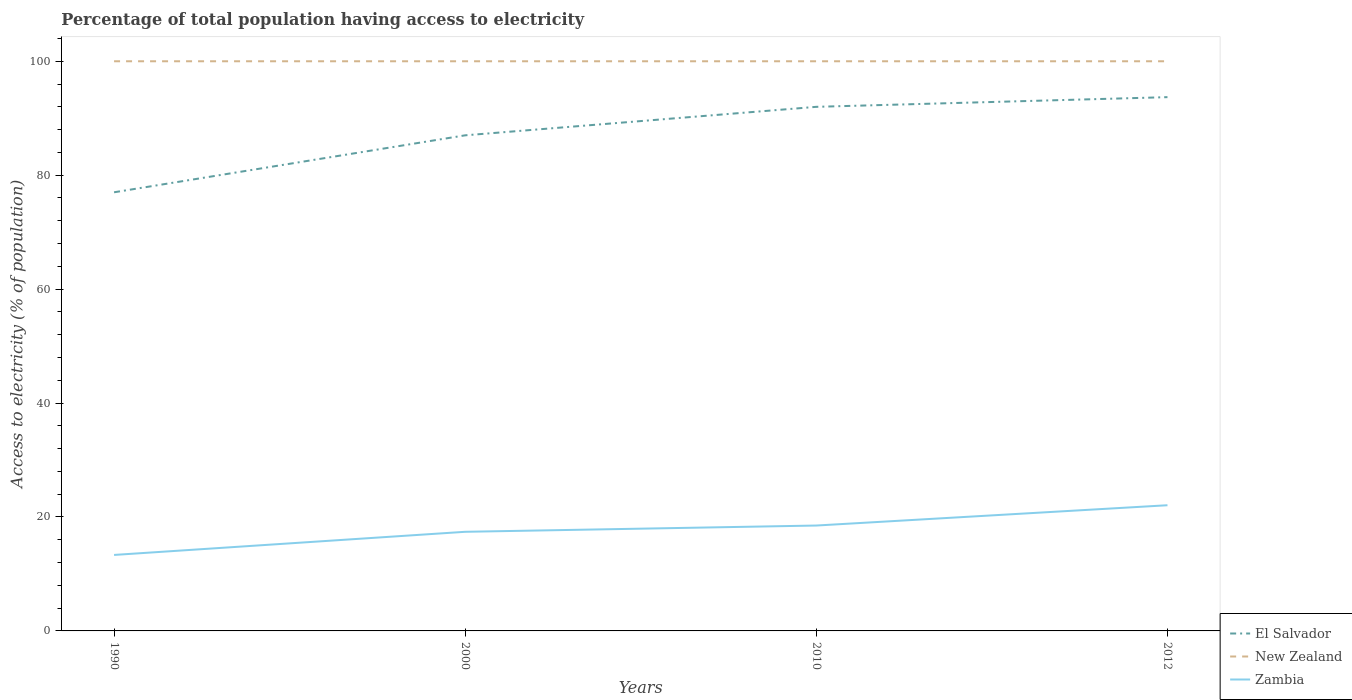How many different coloured lines are there?
Keep it short and to the point. 3. Across all years, what is the maximum percentage of population that have access to electricity in Zambia?
Your answer should be very brief. 13.34. What is the total percentage of population that have access to electricity in New Zealand in the graph?
Offer a very short reply. 0. What is the difference between the highest and the second highest percentage of population that have access to electricity in New Zealand?
Provide a short and direct response. 0. What is the difference between two consecutive major ticks on the Y-axis?
Keep it short and to the point. 20. Are the values on the major ticks of Y-axis written in scientific E-notation?
Your answer should be very brief. No. How are the legend labels stacked?
Make the answer very short. Vertical. What is the title of the graph?
Give a very brief answer. Percentage of total population having access to electricity. What is the label or title of the X-axis?
Provide a succinct answer. Years. What is the label or title of the Y-axis?
Your answer should be compact. Access to electricity (% of population). What is the Access to electricity (% of population) in Zambia in 1990?
Offer a very short reply. 13.34. What is the Access to electricity (% of population) in El Salvador in 2000?
Ensure brevity in your answer.  87. What is the Access to electricity (% of population) of Zambia in 2000?
Offer a terse response. 17.4. What is the Access to electricity (% of population) of El Salvador in 2010?
Give a very brief answer. 92. What is the Access to electricity (% of population) in New Zealand in 2010?
Offer a very short reply. 100. What is the Access to electricity (% of population) of Zambia in 2010?
Keep it short and to the point. 18.5. What is the Access to electricity (% of population) in El Salvador in 2012?
Provide a short and direct response. 93.7. What is the Access to electricity (% of population) in New Zealand in 2012?
Offer a very short reply. 100. What is the Access to electricity (% of population) of Zambia in 2012?
Offer a very short reply. 22.06. Across all years, what is the maximum Access to electricity (% of population) of El Salvador?
Your answer should be very brief. 93.7. Across all years, what is the maximum Access to electricity (% of population) of Zambia?
Your response must be concise. 22.06. Across all years, what is the minimum Access to electricity (% of population) of El Salvador?
Your response must be concise. 77. Across all years, what is the minimum Access to electricity (% of population) in Zambia?
Your answer should be very brief. 13.34. What is the total Access to electricity (% of population) of El Salvador in the graph?
Give a very brief answer. 349.7. What is the total Access to electricity (% of population) in Zambia in the graph?
Make the answer very short. 71.3. What is the difference between the Access to electricity (% of population) in El Salvador in 1990 and that in 2000?
Provide a short and direct response. -10. What is the difference between the Access to electricity (% of population) in New Zealand in 1990 and that in 2000?
Give a very brief answer. 0. What is the difference between the Access to electricity (% of population) in Zambia in 1990 and that in 2000?
Provide a short and direct response. -4.06. What is the difference between the Access to electricity (% of population) in El Salvador in 1990 and that in 2010?
Give a very brief answer. -15. What is the difference between the Access to electricity (% of population) in New Zealand in 1990 and that in 2010?
Give a very brief answer. 0. What is the difference between the Access to electricity (% of population) of Zambia in 1990 and that in 2010?
Give a very brief answer. -5.16. What is the difference between the Access to electricity (% of population) in El Salvador in 1990 and that in 2012?
Provide a succinct answer. -16.7. What is the difference between the Access to electricity (% of population) of New Zealand in 1990 and that in 2012?
Offer a very short reply. 0. What is the difference between the Access to electricity (% of population) of Zambia in 1990 and that in 2012?
Your response must be concise. -8.72. What is the difference between the Access to electricity (% of population) of New Zealand in 2000 and that in 2010?
Provide a short and direct response. 0. What is the difference between the Access to electricity (% of population) in Zambia in 2000 and that in 2010?
Your response must be concise. -1.1. What is the difference between the Access to electricity (% of population) of El Salvador in 2000 and that in 2012?
Provide a short and direct response. -6.7. What is the difference between the Access to electricity (% of population) of Zambia in 2000 and that in 2012?
Make the answer very short. -4.66. What is the difference between the Access to electricity (% of population) in El Salvador in 2010 and that in 2012?
Give a very brief answer. -1.7. What is the difference between the Access to electricity (% of population) of New Zealand in 2010 and that in 2012?
Make the answer very short. 0. What is the difference between the Access to electricity (% of population) of Zambia in 2010 and that in 2012?
Provide a succinct answer. -3.56. What is the difference between the Access to electricity (% of population) of El Salvador in 1990 and the Access to electricity (% of population) of New Zealand in 2000?
Provide a succinct answer. -23. What is the difference between the Access to electricity (% of population) of El Salvador in 1990 and the Access to electricity (% of population) of Zambia in 2000?
Your answer should be compact. 59.6. What is the difference between the Access to electricity (% of population) in New Zealand in 1990 and the Access to electricity (% of population) in Zambia in 2000?
Your answer should be very brief. 82.6. What is the difference between the Access to electricity (% of population) of El Salvador in 1990 and the Access to electricity (% of population) of Zambia in 2010?
Provide a short and direct response. 58.5. What is the difference between the Access to electricity (% of population) of New Zealand in 1990 and the Access to electricity (% of population) of Zambia in 2010?
Your answer should be compact. 81.5. What is the difference between the Access to electricity (% of population) of El Salvador in 1990 and the Access to electricity (% of population) of Zambia in 2012?
Offer a terse response. 54.94. What is the difference between the Access to electricity (% of population) in New Zealand in 1990 and the Access to electricity (% of population) in Zambia in 2012?
Your answer should be very brief. 77.94. What is the difference between the Access to electricity (% of population) of El Salvador in 2000 and the Access to electricity (% of population) of New Zealand in 2010?
Offer a terse response. -13. What is the difference between the Access to electricity (% of population) of El Salvador in 2000 and the Access to electricity (% of population) of Zambia in 2010?
Your answer should be compact. 68.5. What is the difference between the Access to electricity (% of population) of New Zealand in 2000 and the Access to electricity (% of population) of Zambia in 2010?
Ensure brevity in your answer.  81.5. What is the difference between the Access to electricity (% of population) in El Salvador in 2000 and the Access to electricity (% of population) in New Zealand in 2012?
Ensure brevity in your answer.  -13. What is the difference between the Access to electricity (% of population) in El Salvador in 2000 and the Access to electricity (% of population) in Zambia in 2012?
Give a very brief answer. 64.94. What is the difference between the Access to electricity (% of population) in New Zealand in 2000 and the Access to electricity (% of population) in Zambia in 2012?
Your answer should be compact. 77.94. What is the difference between the Access to electricity (% of population) in El Salvador in 2010 and the Access to electricity (% of population) in New Zealand in 2012?
Make the answer very short. -8. What is the difference between the Access to electricity (% of population) in El Salvador in 2010 and the Access to electricity (% of population) in Zambia in 2012?
Give a very brief answer. 69.94. What is the difference between the Access to electricity (% of population) in New Zealand in 2010 and the Access to electricity (% of population) in Zambia in 2012?
Offer a very short reply. 77.94. What is the average Access to electricity (% of population) of El Salvador per year?
Provide a succinct answer. 87.42. What is the average Access to electricity (% of population) in New Zealand per year?
Provide a succinct answer. 100. What is the average Access to electricity (% of population) of Zambia per year?
Provide a succinct answer. 17.83. In the year 1990, what is the difference between the Access to electricity (% of population) of El Salvador and Access to electricity (% of population) of Zambia?
Ensure brevity in your answer.  63.66. In the year 1990, what is the difference between the Access to electricity (% of population) of New Zealand and Access to electricity (% of population) of Zambia?
Keep it short and to the point. 86.66. In the year 2000, what is the difference between the Access to electricity (% of population) of El Salvador and Access to electricity (% of population) of Zambia?
Make the answer very short. 69.6. In the year 2000, what is the difference between the Access to electricity (% of population) of New Zealand and Access to electricity (% of population) of Zambia?
Keep it short and to the point. 82.6. In the year 2010, what is the difference between the Access to electricity (% of population) in El Salvador and Access to electricity (% of population) in New Zealand?
Give a very brief answer. -8. In the year 2010, what is the difference between the Access to electricity (% of population) of El Salvador and Access to electricity (% of population) of Zambia?
Your answer should be compact. 73.5. In the year 2010, what is the difference between the Access to electricity (% of population) in New Zealand and Access to electricity (% of population) in Zambia?
Provide a short and direct response. 81.5. In the year 2012, what is the difference between the Access to electricity (% of population) in El Salvador and Access to electricity (% of population) in New Zealand?
Make the answer very short. -6.3. In the year 2012, what is the difference between the Access to electricity (% of population) in El Salvador and Access to electricity (% of population) in Zambia?
Ensure brevity in your answer.  71.64. In the year 2012, what is the difference between the Access to electricity (% of population) in New Zealand and Access to electricity (% of population) in Zambia?
Give a very brief answer. 77.94. What is the ratio of the Access to electricity (% of population) in El Salvador in 1990 to that in 2000?
Your answer should be very brief. 0.89. What is the ratio of the Access to electricity (% of population) of Zambia in 1990 to that in 2000?
Your response must be concise. 0.77. What is the ratio of the Access to electricity (% of population) of El Salvador in 1990 to that in 2010?
Your response must be concise. 0.84. What is the ratio of the Access to electricity (% of population) in New Zealand in 1990 to that in 2010?
Your answer should be compact. 1. What is the ratio of the Access to electricity (% of population) in Zambia in 1990 to that in 2010?
Provide a short and direct response. 0.72. What is the ratio of the Access to electricity (% of population) in El Salvador in 1990 to that in 2012?
Ensure brevity in your answer.  0.82. What is the ratio of the Access to electricity (% of population) in Zambia in 1990 to that in 2012?
Your response must be concise. 0.6. What is the ratio of the Access to electricity (% of population) in El Salvador in 2000 to that in 2010?
Your response must be concise. 0.95. What is the ratio of the Access to electricity (% of population) in New Zealand in 2000 to that in 2010?
Keep it short and to the point. 1. What is the ratio of the Access to electricity (% of population) in Zambia in 2000 to that in 2010?
Offer a very short reply. 0.94. What is the ratio of the Access to electricity (% of population) of El Salvador in 2000 to that in 2012?
Provide a succinct answer. 0.93. What is the ratio of the Access to electricity (% of population) in Zambia in 2000 to that in 2012?
Keep it short and to the point. 0.79. What is the ratio of the Access to electricity (% of population) in El Salvador in 2010 to that in 2012?
Give a very brief answer. 0.98. What is the ratio of the Access to electricity (% of population) in New Zealand in 2010 to that in 2012?
Give a very brief answer. 1. What is the ratio of the Access to electricity (% of population) of Zambia in 2010 to that in 2012?
Your answer should be very brief. 0.84. What is the difference between the highest and the second highest Access to electricity (% of population) of New Zealand?
Your response must be concise. 0. What is the difference between the highest and the second highest Access to electricity (% of population) of Zambia?
Provide a short and direct response. 3.56. What is the difference between the highest and the lowest Access to electricity (% of population) of Zambia?
Your answer should be very brief. 8.72. 